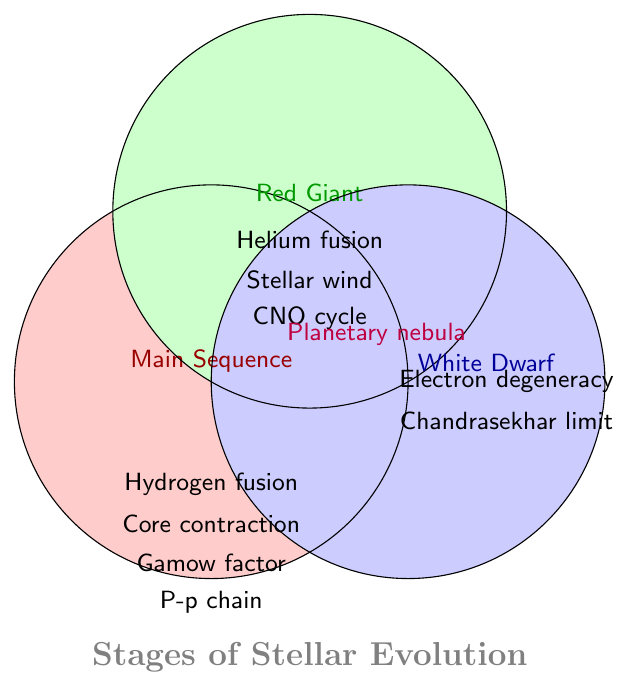What are the titles of the three stages shown in the Venn Diagram? The titles are usually written at the top or within each circle. According to the data, the stages shown in the Venn Diagram are Main Sequence, Red Giant, and White Dwarf.
Answer: Main Sequence, Red Giant, White Dwarf Which stellar evolutionary stage involves hydrogen fusion? To find this, look for "Hydrogen fusion" and see where it is placed. It is placed in the circle representing Main Sequence and Red Giant.
Answer: Main Sequence, Red Giant Does the White Dwarf stage involve any type of fusion? Check for the words "Helium fusion" or "Hydrogen fusion" within the White Dwarf circle. Neither of these terms is present in the White Dwarf section.
Answer: No Which stages involve core contraction? Look where "Core contraction" is listed in the Venn Diagram. It is in the Main Sequence and Red Giant circles.
Answer: Main Sequence, Red Giant What type of cycle is shared between Main Sequence and Red Giant stages? Check for any label that appears in both Main Sequence and Red Giant, but not in White Dwarf. The "CNO cycle" fits this criterion.
Answer: CNO cycle Which stage involves the Chandrasekhar limit? This information can be identified by looking at the circle/place where "Chandrasekhar limit" is written. It is listed under the White Dwarf stage.
Answer: White Dwarf In which stage is the Gamow factor important? See where "Gamow factor important" is placed in the Venn Diagram. It is found in the Main Sequence circle.
Answer: Main Sequence Does Planetary nebula formation appear in more than one stage? If yes, which ones? Look for "Planetary nebula formation" in the Venn Diagram. It appears in both the Red Giant and White Dwarf circles.
Answer: Yes, Red Giant and White Dwarf Which stage has Electron Degeneracy as a key process? Check where "Electron degeneracy" is found in the Venn Diagram. It is found in the White Dwarf circle.
Answer: White Dwarf How many stages involve the CNO cycle? Count the number of stages in which "CNO cycle" appears. It appears in both the Main Sequence and Red Giant stages.
Answer: Two 